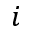<formula> <loc_0><loc_0><loc_500><loc_500>i</formula> 